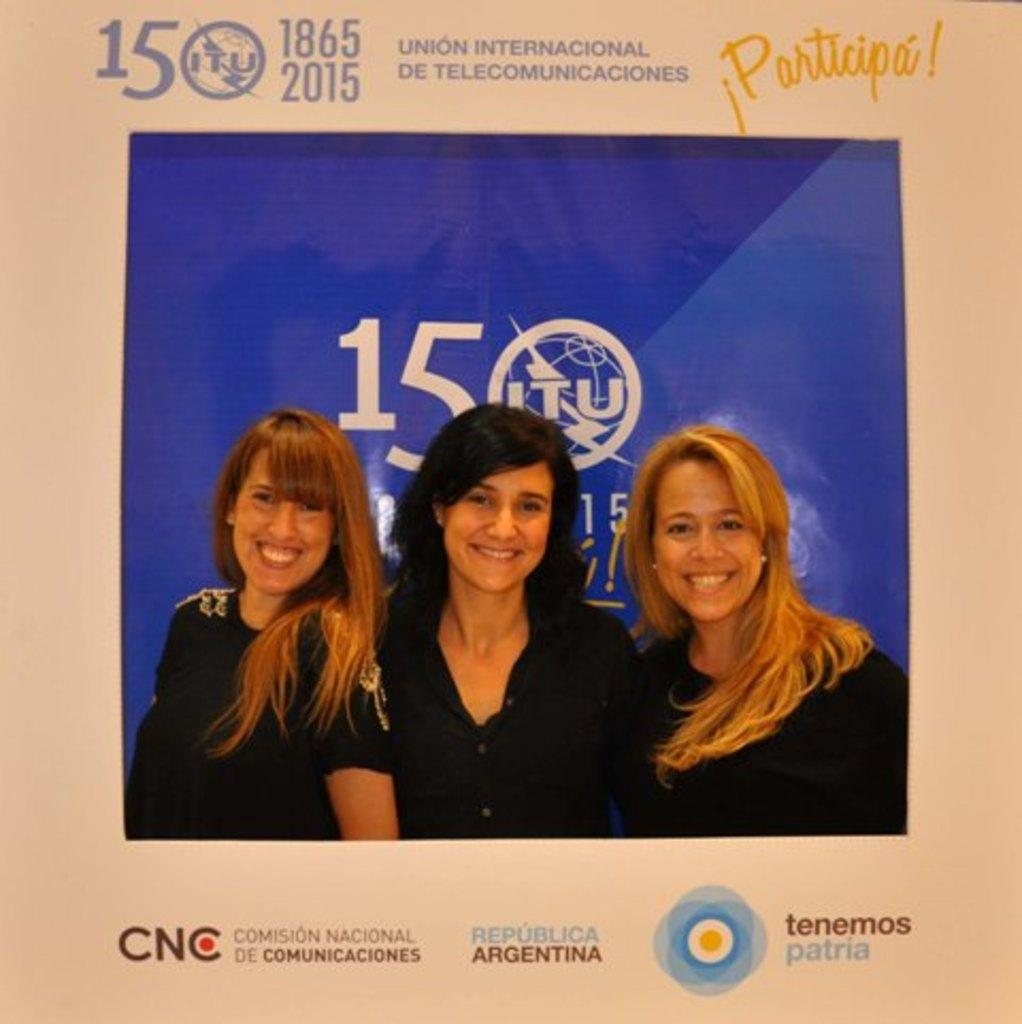What type of object is the image? The image is a photo frame. What is depicted in the photo within the frame? The photo contains three women. What color is the background of the photo? The background of the photo is blue. What other information is present around the photo frame? There are names of different sponsors and a company name around the photo frame. What type of structure is the face of the woman in the photo frame? There is no face present in the image, as it is a photo of three women. Is there a slip of paper visible in the photo frame? There is no slip of paper visible in the photo frame; the image only contains the photo of the three women and the surrounding information. 